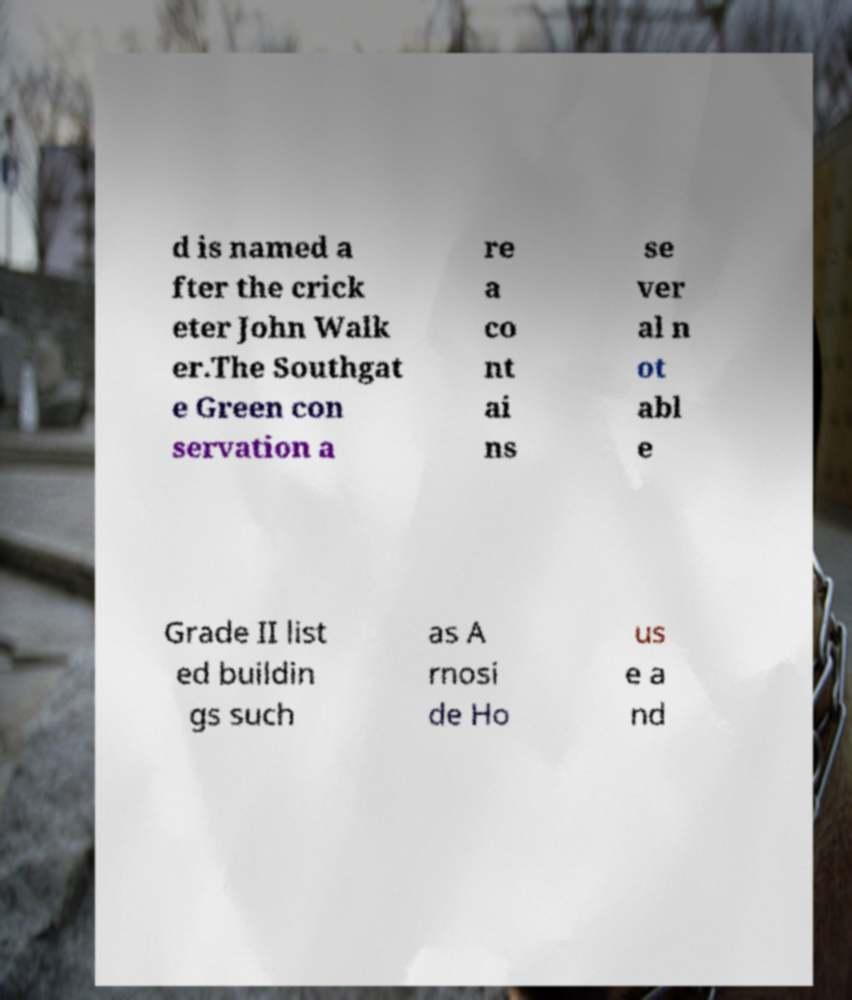What messages or text are displayed in this image? I need them in a readable, typed format. d is named a fter the crick eter John Walk er.The Southgat e Green con servation a re a co nt ai ns se ver al n ot abl e Grade II list ed buildin gs such as A rnosi de Ho us e a nd 